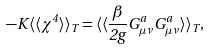<formula> <loc_0><loc_0><loc_500><loc_500>- K \langle \langle \chi ^ { 4 } \rangle \rangle _ { T } = \langle \langle \frac { \beta } { 2 g } G _ { \mu \nu } ^ { a } G _ { \mu \nu } ^ { a } \rangle \rangle _ { T } ,</formula> 